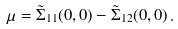<formula> <loc_0><loc_0><loc_500><loc_500>\mu = \tilde { \Sigma } _ { 1 1 } ( 0 , 0 ) - \tilde { \Sigma } _ { 1 2 } ( 0 , 0 ) \, .</formula> 